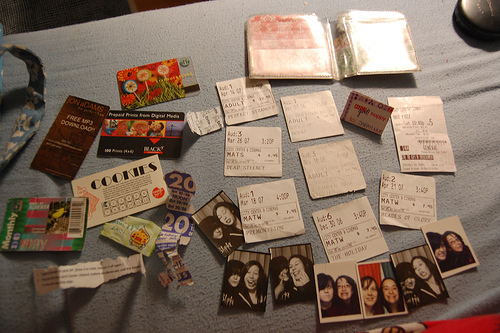<image>
Can you confirm if the paper is to the left of the paper? No. The paper is not to the left of the paper. From this viewpoint, they have a different horizontal relationship. 